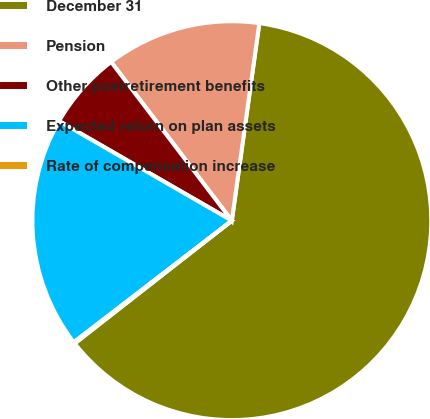Convert chart to OTSL. <chart><loc_0><loc_0><loc_500><loc_500><pie_chart><fcel>December 31<fcel>Pension<fcel>Other postretirement benefits<fcel>Expected return on plan assets<fcel>Rate of compensation increase<nl><fcel>62.24%<fcel>12.55%<fcel>6.33%<fcel>18.76%<fcel>0.12%<nl></chart> 